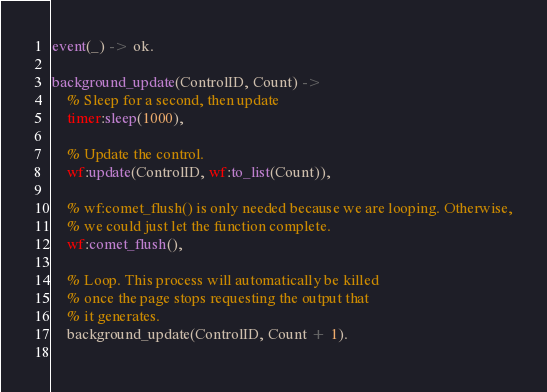<code> <loc_0><loc_0><loc_500><loc_500><_Erlang_>
event(_) -> ok.

background_update(ControlID, Count) ->
	% Sleep for a second, then update
	timer:sleep(1000),
	
	% Update the control.
	wf:update(ControlID, wf:to_list(Count)),
	
	% wf:comet_flush() is only needed because we are looping. Otherwise,
	% we could just let the function complete.
	wf:comet_flush(),

	% Loop. This process will automatically be killed
	% once the page stops requesting the output that
	% it generates.
	background_update(ControlID, Count + 1).
	
</code> 